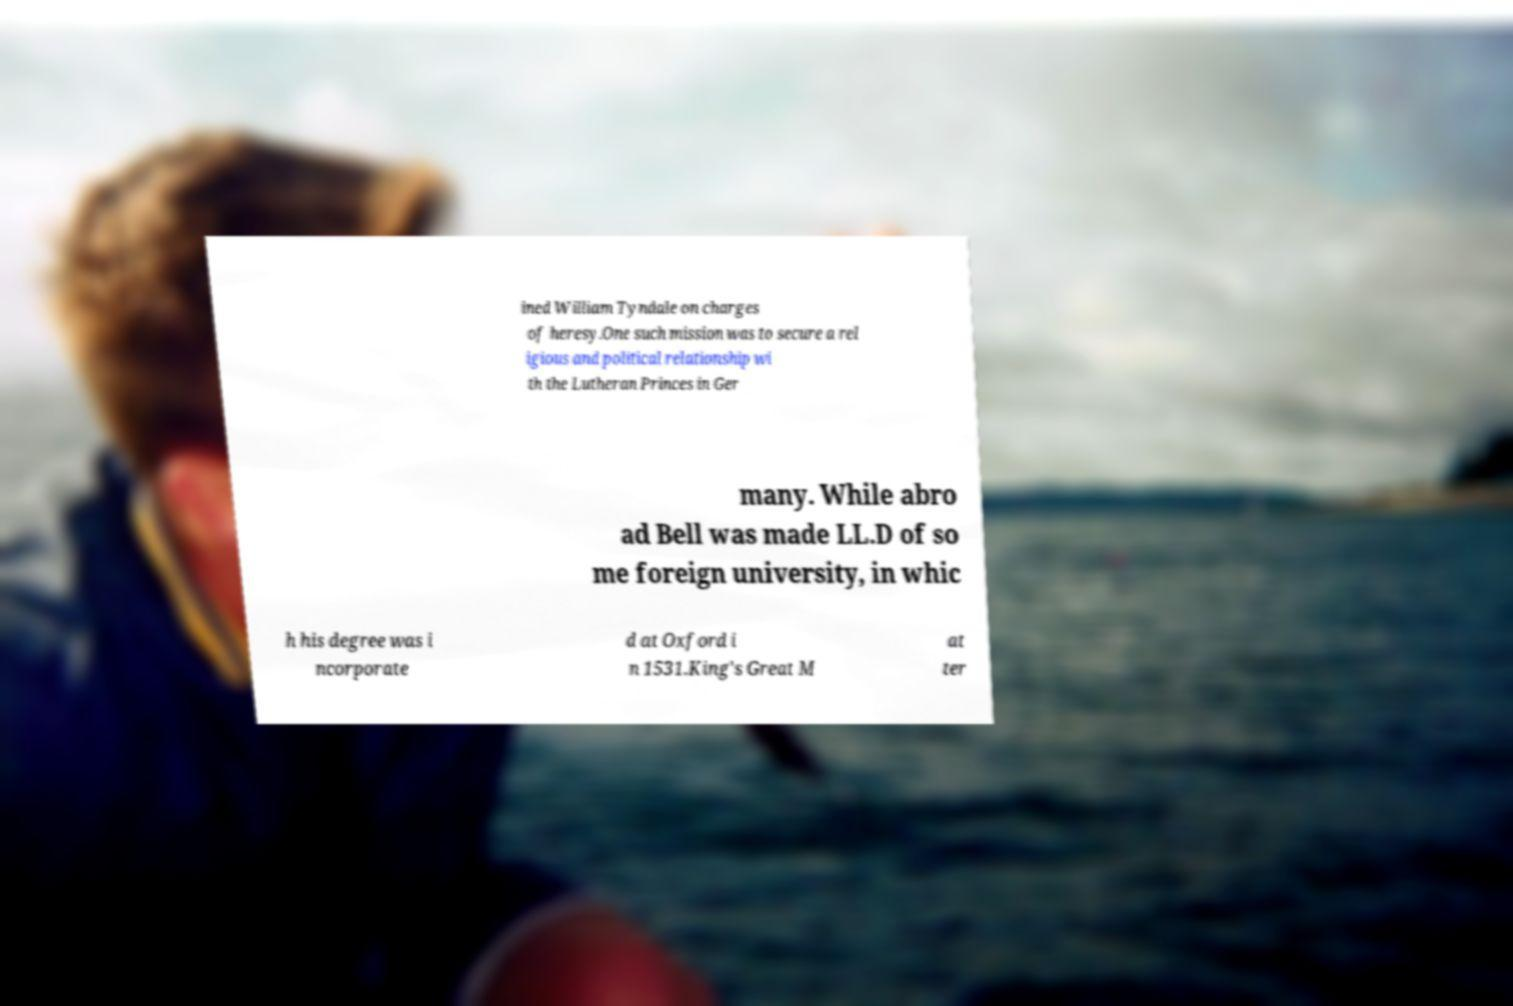Can you accurately transcribe the text from the provided image for me? ined William Tyndale on charges of heresy.One such mission was to secure a rel igious and political relationship wi th the Lutheran Princes in Ger many. While abro ad Bell was made LL.D of so me foreign university, in whic h his degree was i ncorporate d at Oxford i n 1531.King's Great M at ter 